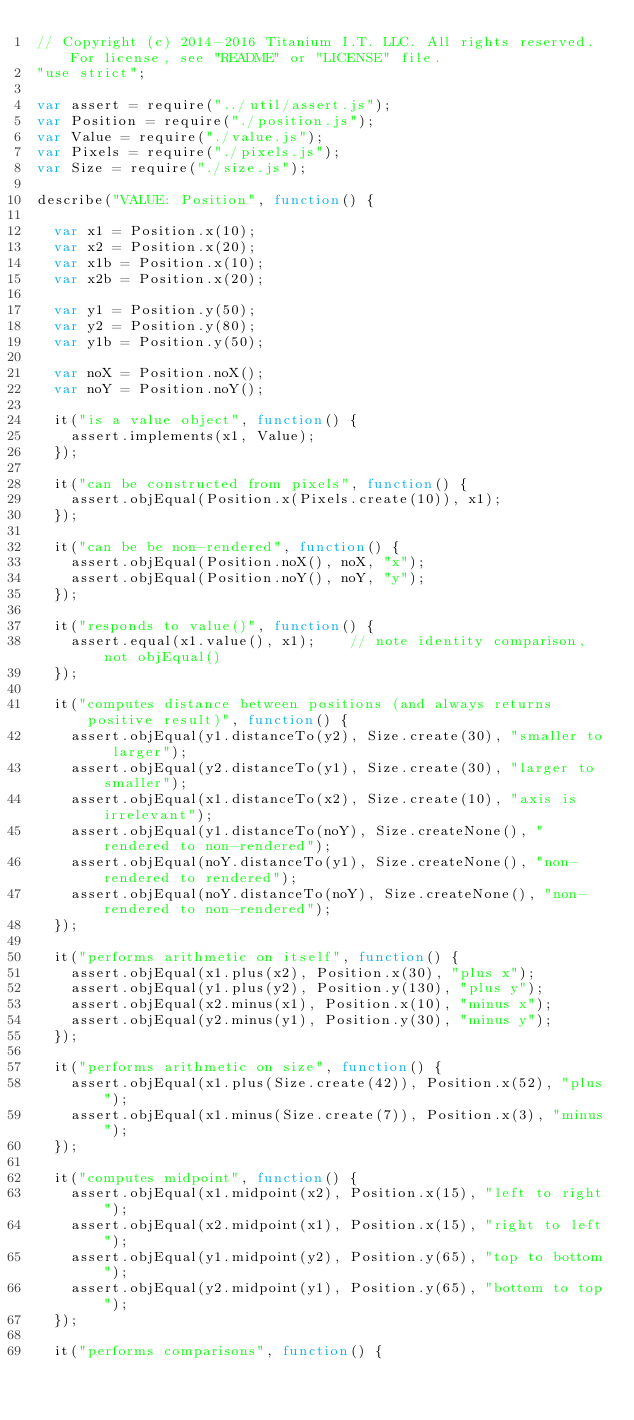<code> <loc_0><loc_0><loc_500><loc_500><_JavaScript_>// Copyright (c) 2014-2016 Titanium I.T. LLC. All rights reserved. For license, see "README" or "LICENSE" file.
"use strict";

var assert = require("../util/assert.js");
var Position = require("./position.js");
var Value = require("./value.js");
var Pixels = require("./pixels.js");
var Size = require("./size.js");

describe("VALUE: Position", function() {

	var x1 = Position.x(10);
	var x2 = Position.x(20);
	var x1b = Position.x(10);
	var x2b = Position.x(20);

	var y1 = Position.y(50);
	var y2 = Position.y(80);
	var y1b = Position.y(50);

	var noX = Position.noX();
	var noY = Position.noY();

	it("is a value object", function() {
		assert.implements(x1, Value);
	});

	it("can be constructed from pixels", function() {
		assert.objEqual(Position.x(Pixels.create(10)), x1);
	});

	it("can be be non-rendered", function() {
		assert.objEqual(Position.noX(), noX, "x");
		assert.objEqual(Position.noY(), noY, "y");
	});

	it("responds to value()", function() {
		assert.equal(x1.value(), x1);    // note identity comparison, not objEqual()
	});

	it("computes distance between positions (and always returns positive result)", function() {
		assert.objEqual(y1.distanceTo(y2), Size.create(30), "smaller to larger");
		assert.objEqual(y2.distanceTo(y1), Size.create(30), "larger to smaller");
		assert.objEqual(x1.distanceTo(x2), Size.create(10), "axis is irrelevant");
		assert.objEqual(y1.distanceTo(noY), Size.createNone(), "rendered to non-rendered");
		assert.objEqual(noY.distanceTo(y1), Size.createNone(), "non-rendered to rendered");
		assert.objEqual(noY.distanceTo(noY), Size.createNone(), "non-rendered to non-rendered");
	});

	it("performs arithmetic on itself", function() {
		assert.objEqual(x1.plus(x2), Position.x(30), "plus x");
		assert.objEqual(y1.plus(y2), Position.y(130), "plus y");
		assert.objEqual(x2.minus(x1), Position.x(10), "minus x");
		assert.objEqual(y2.minus(y1), Position.y(30), "minus y");
	});

	it("performs arithmetic on size", function() {
		assert.objEqual(x1.plus(Size.create(42)), Position.x(52), "plus");
		assert.objEqual(x1.minus(Size.create(7)), Position.x(3), "minus");
	});

	it("computes midpoint", function() {
		assert.objEqual(x1.midpoint(x2), Position.x(15), "left to right");
		assert.objEqual(x2.midpoint(x1), Position.x(15), "right to left");
		assert.objEqual(y1.midpoint(y2), Position.y(65), "top to bottom");
		assert.objEqual(y2.midpoint(y1), Position.y(65), "bottom to top");
	});

	it("performs comparisons", function() {</code> 